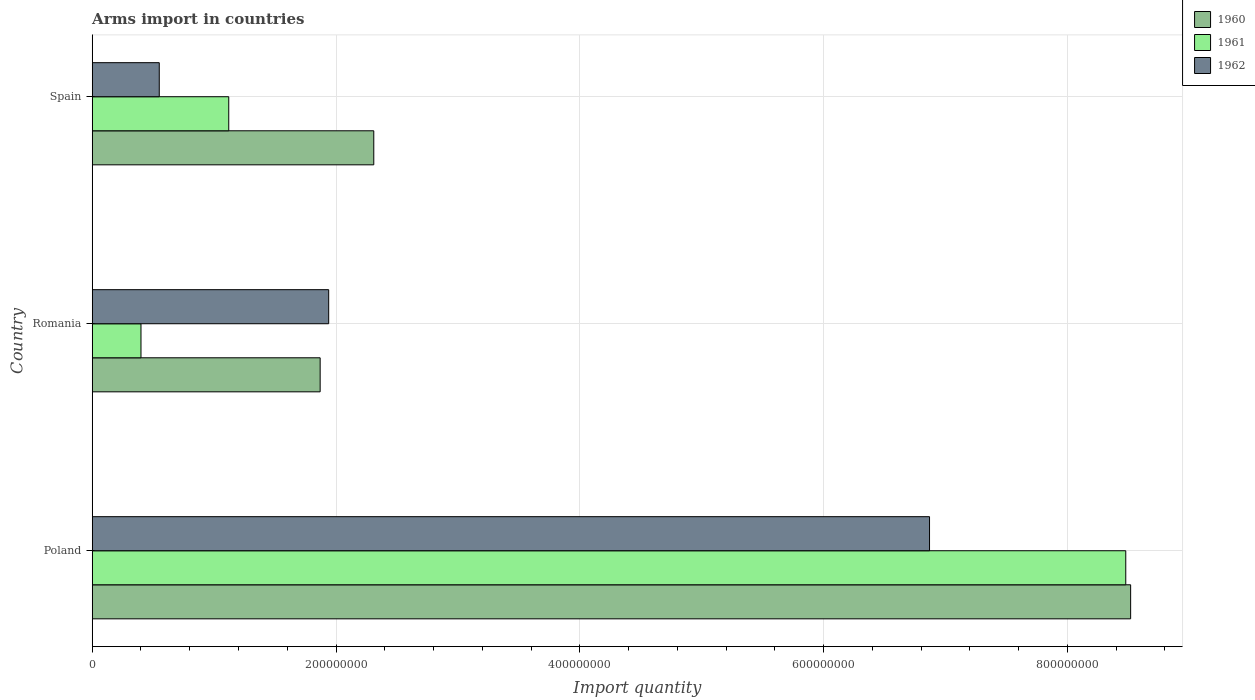Are the number of bars on each tick of the Y-axis equal?
Give a very brief answer. Yes. How many bars are there on the 3rd tick from the top?
Provide a succinct answer. 3. How many bars are there on the 1st tick from the bottom?
Your response must be concise. 3. What is the label of the 2nd group of bars from the top?
Make the answer very short. Romania. In how many cases, is the number of bars for a given country not equal to the number of legend labels?
Make the answer very short. 0. What is the total arms import in 1962 in Poland?
Offer a very short reply. 6.87e+08. Across all countries, what is the maximum total arms import in 1962?
Ensure brevity in your answer.  6.87e+08. Across all countries, what is the minimum total arms import in 1962?
Your answer should be compact. 5.50e+07. In which country was the total arms import in 1960 minimum?
Provide a short and direct response. Romania. What is the total total arms import in 1962 in the graph?
Provide a succinct answer. 9.36e+08. What is the difference between the total arms import in 1962 in Romania and that in Spain?
Your response must be concise. 1.39e+08. What is the difference between the total arms import in 1960 in Romania and the total arms import in 1961 in Poland?
Give a very brief answer. -6.61e+08. What is the average total arms import in 1961 per country?
Give a very brief answer. 3.33e+08. What is the difference between the total arms import in 1960 and total arms import in 1961 in Spain?
Your response must be concise. 1.19e+08. In how many countries, is the total arms import in 1961 greater than 760000000 ?
Offer a terse response. 1. What is the ratio of the total arms import in 1961 in Poland to that in Spain?
Ensure brevity in your answer.  7.57. Is the total arms import in 1961 in Romania less than that in Spain?
Your answer should be compact. Yes. What is the difference between the highest and the second highest total arms import in 1962?
Keep it short and to the point. 4.93e+08. What is the difference between the highest and the lowest total arms import in 1960?
Ensure brevity in your answer.  6.65e+08. In how many countries, is the total arms import in 1961 greater than the average total arms import in 1961 taken over all countries?
Your response must be concise. 1. Is the sum of the total arms import in 1962 in Poland and Romania greater than the maximum total arms import in 1960 across all countries?
Make the answer very short. Yes. What does the 2nd bar from the bottom in Romania represents?
Provide a short and direct response. 1961. How many bars are there?
Offer a terse response. 9. How many countries are there in the graph?
Your answer should be very brief. 3. Does the graph contain grids?
Provide a succinct answer. Yes. Where does the legend appear in the graph?
Your answer should be compact. Top right. How many legend labels are there?
Offer a very short reply. 3. What is the title of the graph?
Provide a succinct answer. Arms import in countries. Does "1988" appear as one of the legend labels in the graph?
Your answer should be compact. No. What is the label or title of the X-axis?
Keep it short and to the point. Import quantity. What is the Import quantity of 1960 in Poland?
Keep it short and to the point. 8.52e+08. What is the Import quantity of 1961 in Poland?
Provide a short and direct response. 8.48e+08. What is the Import quantity of 1962 in Poland?
Make the answer very short. 6.87e+08. What is the Import quantity of 1960 in Romania?
Give a very brief answer. 1.87e+08. What is the Import quantity of 1961 in Romania?
Offer a terse response. 4.00e+07. What is the Import quantity of 1962 in Romania?
Make the answer very short. 1.94e+08. What is the Import quantity in 1960 in Spain?
Make the answer very short. 2.31e+08. What is the Import quantity of 1961 in Spain?
Give a very brief answer. 1.12e+08. What is the Import quantity in 1962 in Spain?
Make the answer very short. 5.50e+07. Across all countries, what is the maximum Import quantity in 1960?
Make the answer very short. 8.52e+08. Across all countries, what is the maximum Import quantity of 1961?
Ensure brevity in your answer.  8.48e+08. Across all countries, what is the maximum Import quantity of 1962?
Your answer should be very brief. 6.87e+08. Across all countries, what is the minimum Import quantity of 1960?
Your answer should be very brief. 1.87e+08. Across all countries, what is the minimum Import quantity in 1961?
Keep it short and to the point. 4.00e+07. Across all countries, what is the minimum Import quantity in 1962?
Provide a short and direct response. 5.50e+07. What is the total Import quantity of 1960 in the graph?
Your answer should be compact. 1.27e+09. What is the total Import quantity in 1961 in the graph?
Your answer should be compact. 1.00e+09. What is the total Import quantity of 1962 in the graph?
Ensure brevity in your answer.  9.36e+08. What is the difference between the Import quantity of 1960 in Poland and that in Romania?
Your answer should be very brief. 6.65e+08. What is the difference between the Import quantity in 1961 in Poland and that in Romania?
Make the answer very short. 8.08e+08. What is the difference between the Import quantity of 1962 in Poland and that in Romania?
Offer a very short reply. 4.93e+08. What is the difference between the Import quantity in 1960 in Poland and that in Spain?
Provide a succinct answer. 6.21e+08. What is the difference between the Import quantity of 1961 in Poland and that in Spain?
Provide a succinct answer. 7.36e+08. What is the difference between the Import quantity in 1962 in Poland and that in Spain?
Offer a terse response. 6.32e+08. What is the difference between the Import quantity in 1960 in Romania and that in Spain?
Offer a terse response. -4.40e+07. What is the difference between the Import quantity of 1961 in Romania and that in Spain?
Ensure brevity in your answer.  -7.20e+07. What is the difference between the Import quantity of 1962 in Romania and that in Spain?
Give a very brief answer. 1.39e+08. What is the difference between the Import quantity in 1960 in Poland and the Import quantity in 1961 in Romania?
Keep it short and to the point. 8.12e+08. What is the difference between the Import quantity in 1960 in Poland and the Import quantity in 1962 in Romania?
Offer a very short reply. 6.58e+08. What is the difference between the Import quantity of 1961 in Poland and the Import quantity of 1962 in Romania?
Provide a succinct answer. 6.54e+08. What is the difference between the Import quantity in 1960 in Poland and the Import quantity in 1961 in Spain?
Keep it short and to the point. 7.40e+08. What is the difference between the Import quantity in 1960 in Poland and the Import quantity in 1962 in Spain?
Ensure brevity in your answer.  7.97e+08. What is the difference between the Import quantity of 1961 in Poland and the Import quantity of 1962 in Spain?
Make the answer very short. 7.93e+08. What is the difference between the Import quantity in 1960 in Romania and the Import quantity in 1961 in Spain?
Offer a terse response. 7.50e+07. What is the difference between the Import quantity in 1960 in Romania and the Import quantity in 1962 in Spain?
Provide a short and direct response. 1.32e+08. What is the difference between the Import quantity in 1961 in Romania and the Import quantity in 1962 in Spain?
Offer a terse response. -1.50e+07. What is the average Import quantity of 1960 per country?
Offer a terse response. 4.23e+08. What is the average Import quantity of 1961 per country?
Keep it short and to the point. 3.33e+08. What is the average Import quantity of 1962 per country?
Provide a short and direct response. 3.12e+08. What is the difference between the Import quantity of 1960 and Import quantity of 1961 in Poland?
Keep it short and to the point. 4.00e+06. What is the difference between the Import quantity of 1960 and Import quantity of 1962 in Poland?
Your response must be concise. 1.65e+08. What is the difference between the Import quantity of 1961 and Import quantity of 1962 in Poland?
Give a very brief answer. 1.61e+08. What is the difference between the Import quantity of 1960 and Import quantity of 1961 in Romania?
Keep it short and to the point. 1.47e+08. What is the difference between the Import quantity in 1960 and Import quantity in 1962 in Romania?
Offer a very short reply. -7.00e+06. What is the difference between the Import quantity in 1961 and Import quantity in 1962 in Romania?
Provide a short and direct response. -1.54e+08. What is the difference between the Import quantity of 1960 and Import quantity of 1961 in Spain?
Provide a succinct answer. 1.19e+08. What is the difference between the Import quantity in 1960 and Import quantity in 1962 in Spain?
Offer a terse response. 1.76e+08. What is the difference between the Import quantity of 1961 and Import quantity of 1962 in Spain?
Your answer should be very brief. 5.70e+07. What is the ratio of the Import quantity in 1960 in Poland to that in Romania?
Your answer should be very brief. 4.56. What is the ratio of the Import quantity in 1961 in Poland to that in Romania?
Give a very brief answer. 21.2. What is the ratio of the Import quantity in 1962 in Poland to that in Romania?
Your response must be concise. 3.54. What is the ratio of the Import quantity in 1960 in Poland to that in Spain?
Your response must be concise. 3.69. What is the ratio of the Import quantity in 1961 in Poland to that in Spain?
Provide a short and direct response. 7.57. What is the ratio of the Import quantity in 1962 in Poland to that in Spain?
Give a very brief answer. 12.49. What is the ratio of the Import quantity in 1960 in Romania to that in Spain?
Ensure brevity in your answer.  0.81. What is the ratio of the Import quantity in 1961 in Romania to that in Spain?
Keep it short and to the point. 0.36. What is the ratio of the Import quantity of 1962 in Romania to that in Spain?
Keep it short and to the point. 3.53. What is the difference between the highest and the second highest Import quantity in 1960?
Give a very brief answer. 6.21e+08. What is the difference between the highest and the second highest Import quantity of 1961?
Your answer should be very brief. 7.36e+08. What is the difference between the highest and the second highest Import quantity of 1962?
Make the answer very short. 4.93e+08. What is the difference between the highest and the lowest Import quantity of 1960?
Provide a succinct answer. 6.65e+08. What is the difference between the highest and the lowest Import quantity of 1961?
Ensure brevity in your answer.  8.08e+08. What is the difference between the highest and the lowest Import quantity in 1962?
Provide a short and direct response. 6.32e+08. 